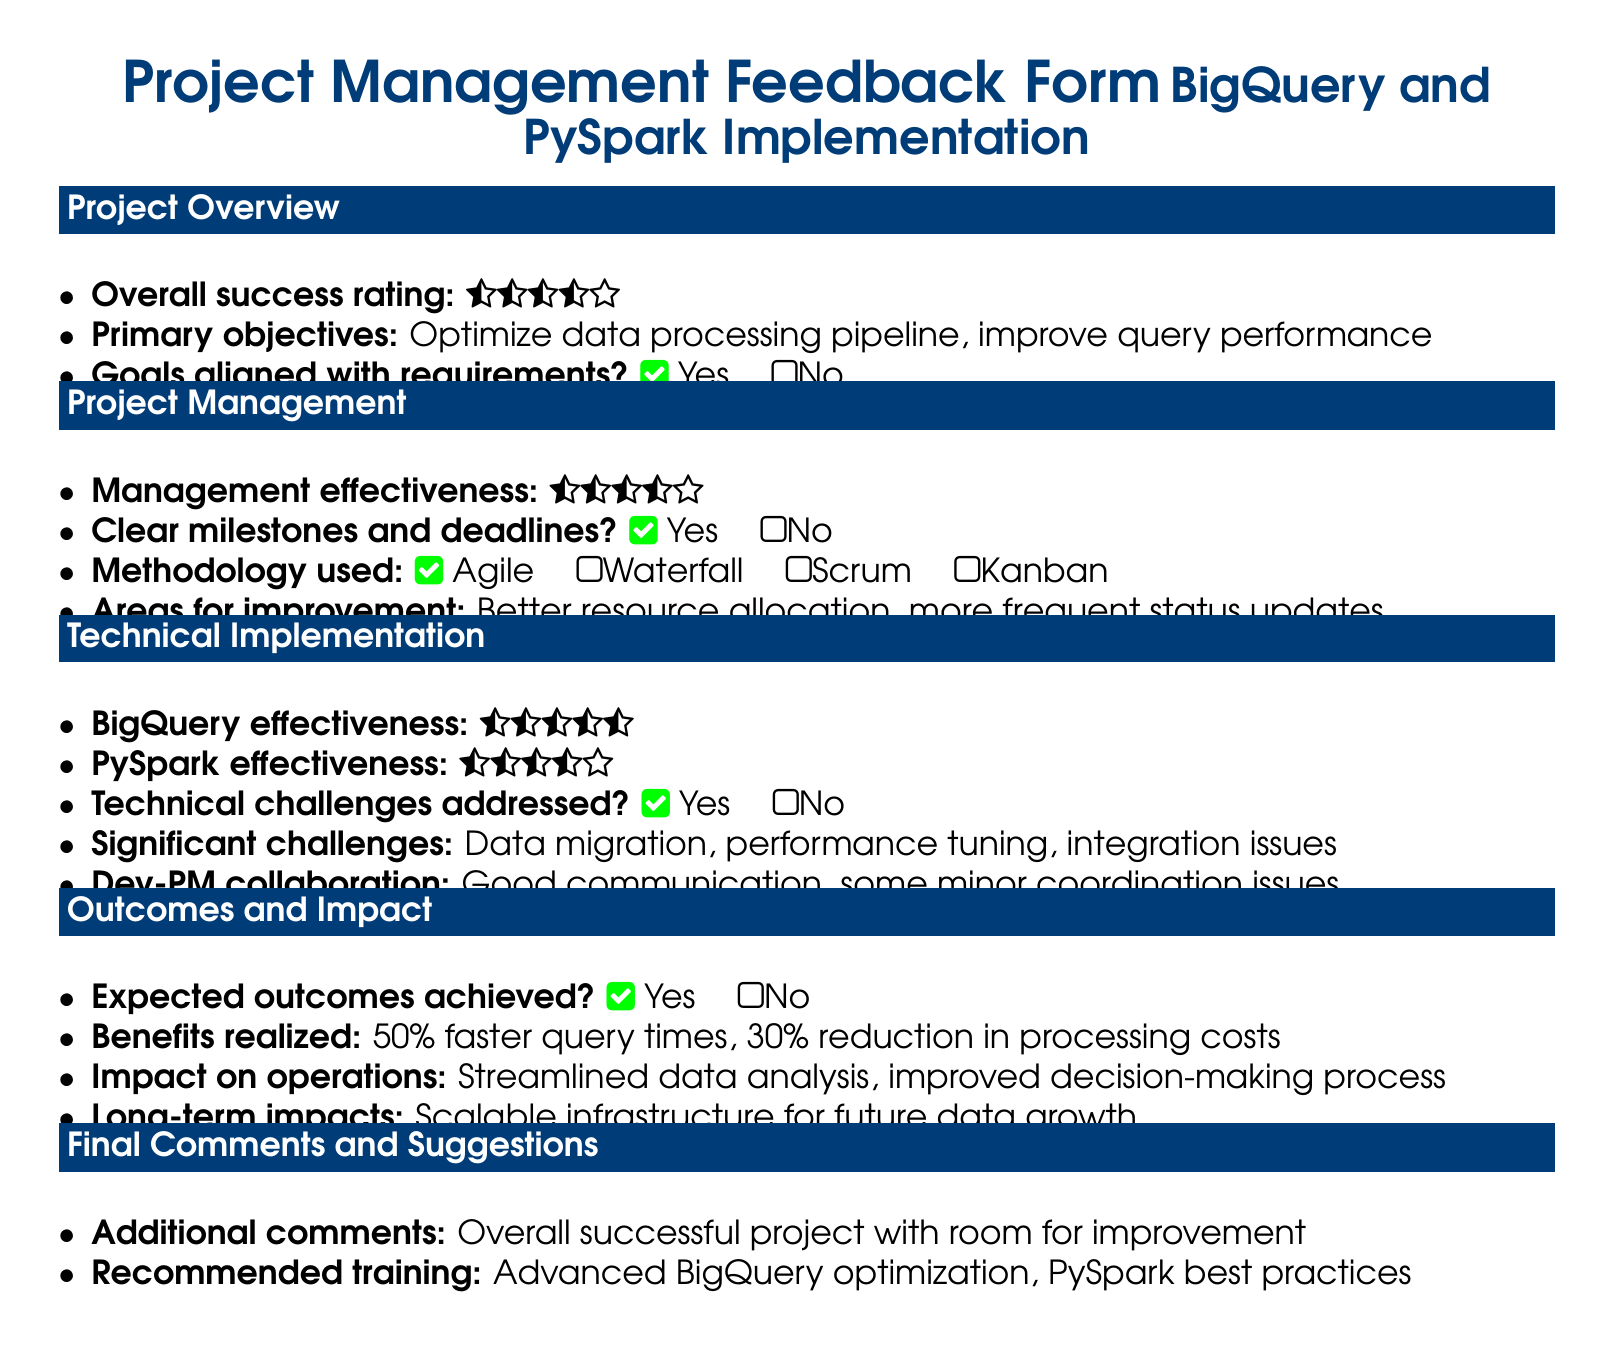what is the overall success rating? The overall success rating is represented by stars, indicating a rating of four stars.
Answer: four stars what are the primary objectives of the project? The primary objectives are listed explicitly: optimize data processing pipeline and improve query performance.
Answer: optimize data processing pipeline, improve query performance how effective is BigQuery according to the feedback? The effectiveness of BigQuery is shown as three and a half stars.
Answer: three and a half stars what challenges were significant during the project? Significant challenges encountered include data migration, performance tuning, and integration issues.
Answer: data migration, performance tuning, integration issues what are the expected benefits of the project? The benefits realized include a 50 percent faster query time and a 30 percent reduction in processing costs.
Answer: 50 percent faster query times, 30 percent reduction in processing costs was the project methodology Agile? The methodology used is indicated as Agile, which is confirmed by a check mark.
Answer: Agile what is one area for improvement mentioned in the document? One area highlighted for improvement is better resource allocation.
Answer: better resource allocation did the project achieve the expected outcomes? The document states that the expected outcomes were achieved, indicated by a check mark.
Answer: Yes what is a recommended training topic? The recommended training topic is advanced BigQuery optimization.
Answer: advanced BigQuery optimization 